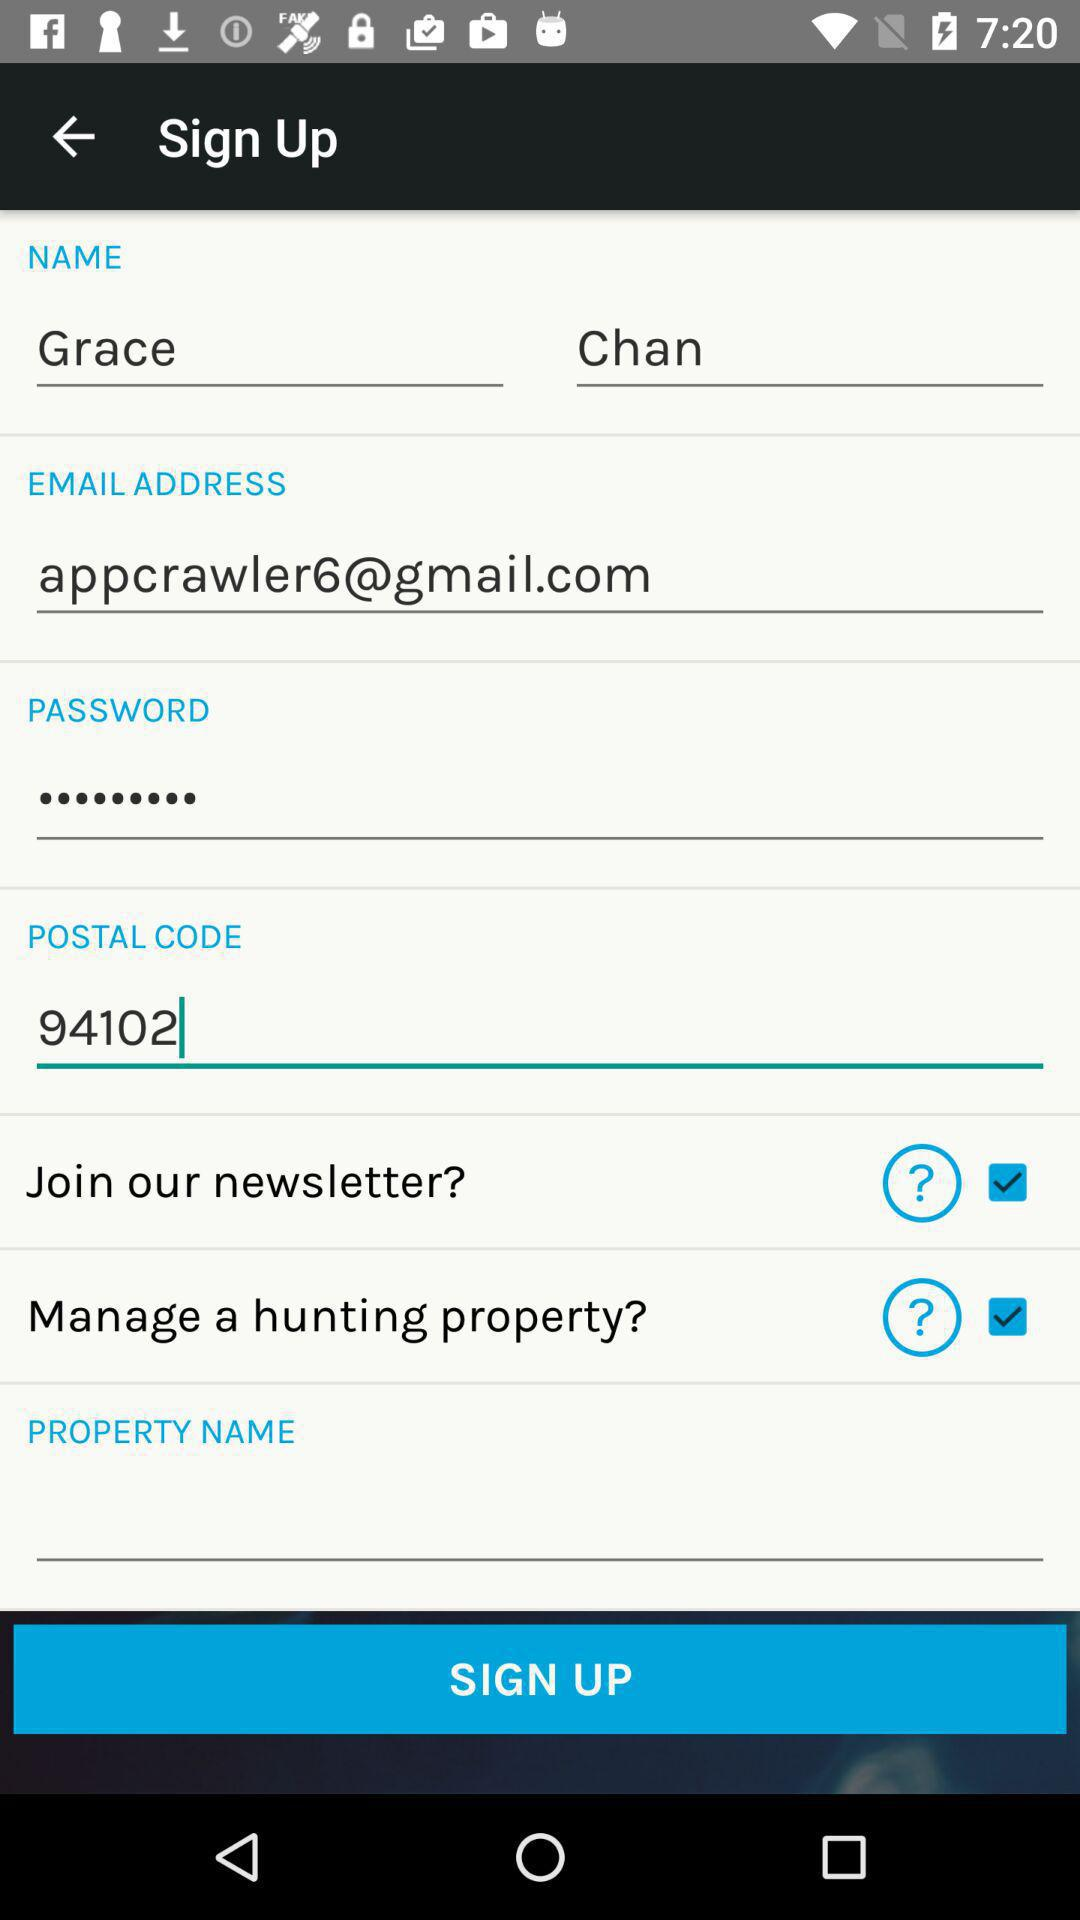What is the status of "Join our newsletter?"? The status is "on". 